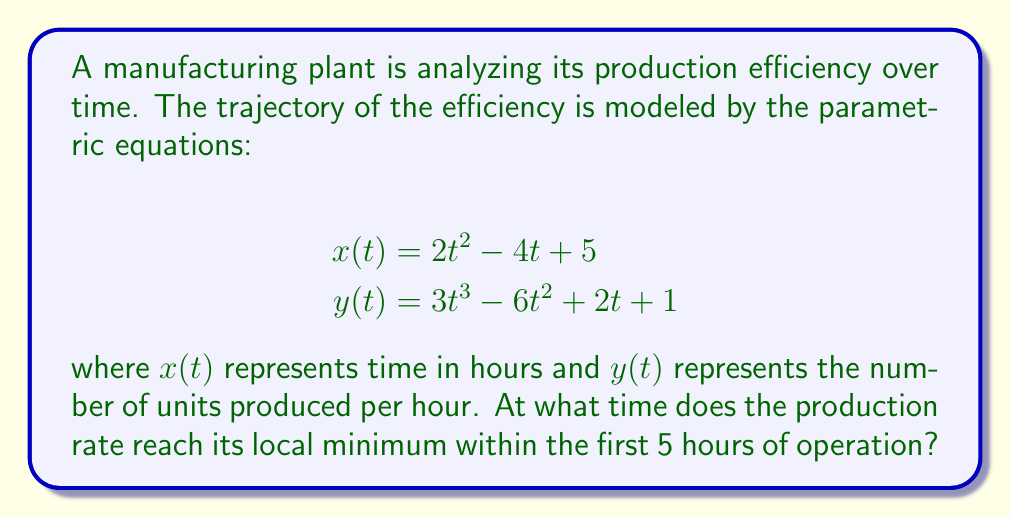Teach me how to tackle this problem. To find the local minimum of the production rate, we need to follow these steps:

1) First, we need to find $\frac{dy}{dx}$. We can do this using the chain rule:

   $$\frac{dy}{dx} = \frac{dy/dt}{dx/dt}$$

2) Let's calculate $\frac{dx}{dt}$ and $\frac{dy}{dt}$:

   $$\frac{dx}{dt} = 4t - 4$$
   $$\frac{dy}{dt} = 9t^2 - 12t + 2$$

3) Now we can form $\frac{dy}{dx}$:

   $$\frac{dy}{dx} = \frac{9t^2 - 12t + 2}{4t - 4}$$

4) At a local minimum or maximum, $\frac{dy}{dx} = 0$. So we set the numerator to zero:

   $$9t^2 - 12t + 2 = 0$$

5) This is a quadratic equation. We can solve it using the quadratic formula:

   $$t = \frac{12 \pm \sqrt{144 - 72}}{18} = \frac{12 \pm \sqrt{72}}{18} = \frac{12 \pm 6\sqrt{2}}{18}$$

6) This gives us two solutions:

   $$t_1 = \frac{12 + 6\sqrt{2}}{18} \approx 1.14$$
   $$t_2 = \frac{12 - 6\sqrt{2}}{18} \approx 0.19$$

7) To determine which of these is a minimum, we can check the second derivative. Alternatively, since we're asked about the first 5 hours, we can observe that $t_1 \approx 1.14$ is within this range while $t_2$ is not.

8) Therefore, the local minimum within the first 5 hours occurs at $t \approx 1.14$ hours.
Answer: The production rate reaches its local minimum at approximately 1.14 hours (or 1 hour and 8 minutes) into the operation. 